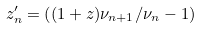Convert formula to latex. <formula><loc_0><loc_0><loc_500><loc_500>z ^ { \prime } _ { n } = \left ( ( 1 + z ) { \nu _ { n + 1 } / \nu _ { n } } - 1 \right )</formula> 